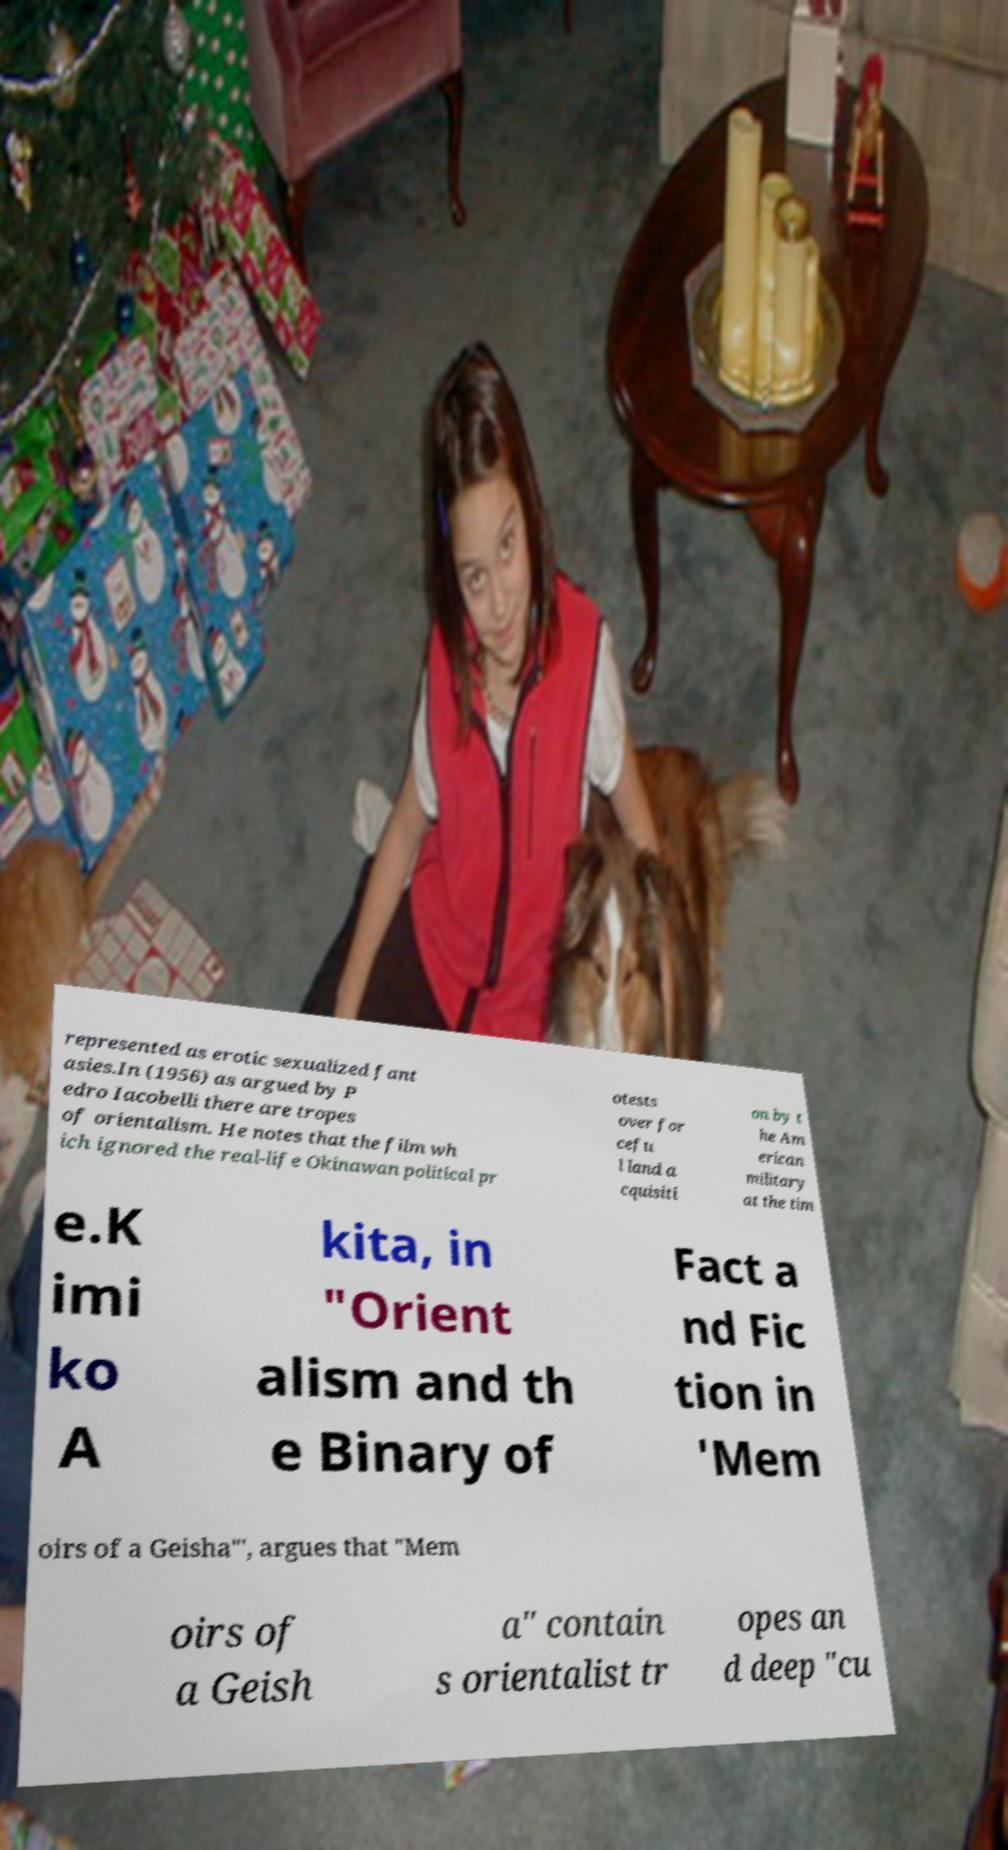Can you read and provide the text displayed in the image?This photo seems to have some interesting text. Can you extract and type it out for me? represented as erotic sexualized fant asies.In (1956) as argued by P edro Iacobelli there are tropes of orientalism. He notes that the film wh ich ignored the real-life Okinawan political pr otests over for cefu l land a cquisiti on by t he Am erican military at the tim e.K imi ko A kita, in "Orient alism and th e Binary of Fact a nd Fic tion in 'Mem oirs of a Geisha"', argues that "Mem oirs of a Geish a" contain s orientalist tr opes an d deep "cu 